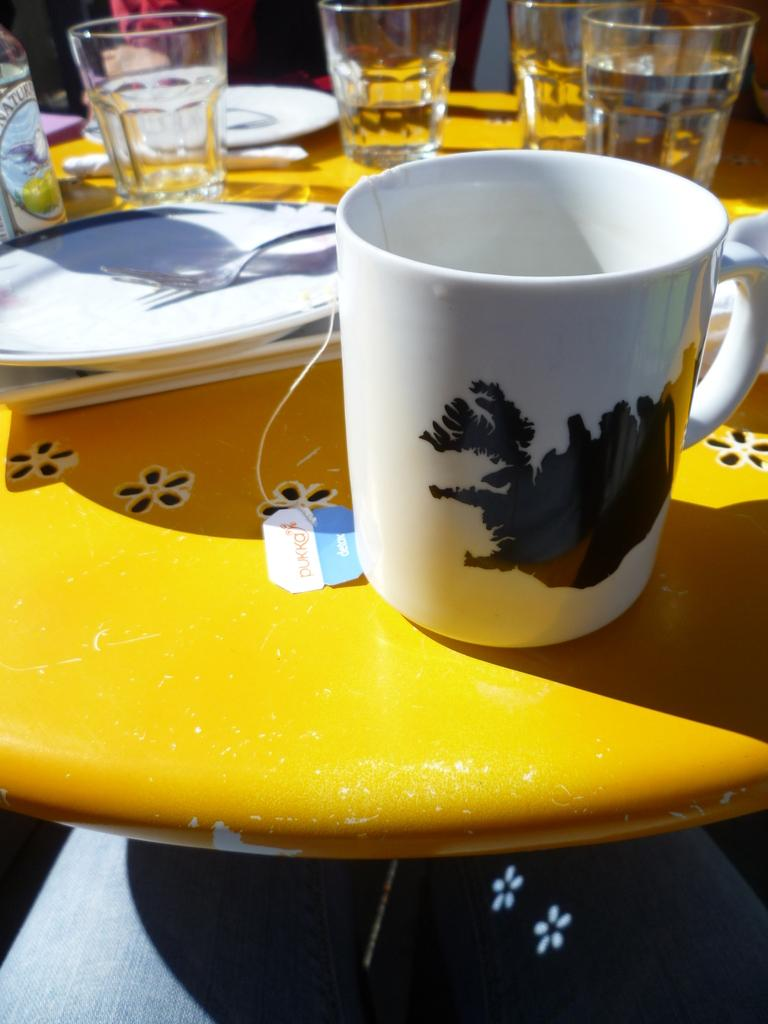What type of tableware can be seen on the table in the image? There are plates, forks, glasses, and a cup on the table in the image. What might be used for eating or drinking in the image? The plates, forks, glasses, and cup on the table can be used for eating or drinking. In which direction is the bike facing in the image? There is no bike present in the image. What is the profit margin of the items on the table in the image? The image does not provide information about the profit margin of the items on the table. 